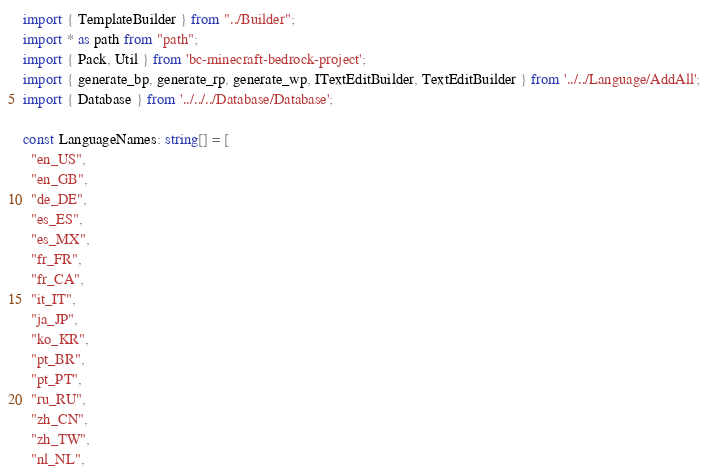Convert code to text. <code><loc_0><loc_0><loc_500><loc_500><_TypeScript_>import { TemplateBuilder } from "../Builder";
import * as path from "path";
import { Pack, Util } from 'bc-minecraft-bedrock-project';
import { generate_bp, generate_rp, generate_wp, ITextEditBuilder, TextEditBuilder } from '../../Language/AddAll';
import { Database } from '../../../Database/Database';

const LanguageNames: string[] = [
  "en_US",
  "en_GB",
  "de_DE",
  "es_ES",
  "es_MX",
  "fr_FR",
  "fr_CA",
  "it_IT",
  "ja_JP",
  "ko_KR",
  "pt_BR",
  "pt_PT",
  "ru_RU",
  "zh_CN",
  "zh_TW",
  "nl_NL",</code> 